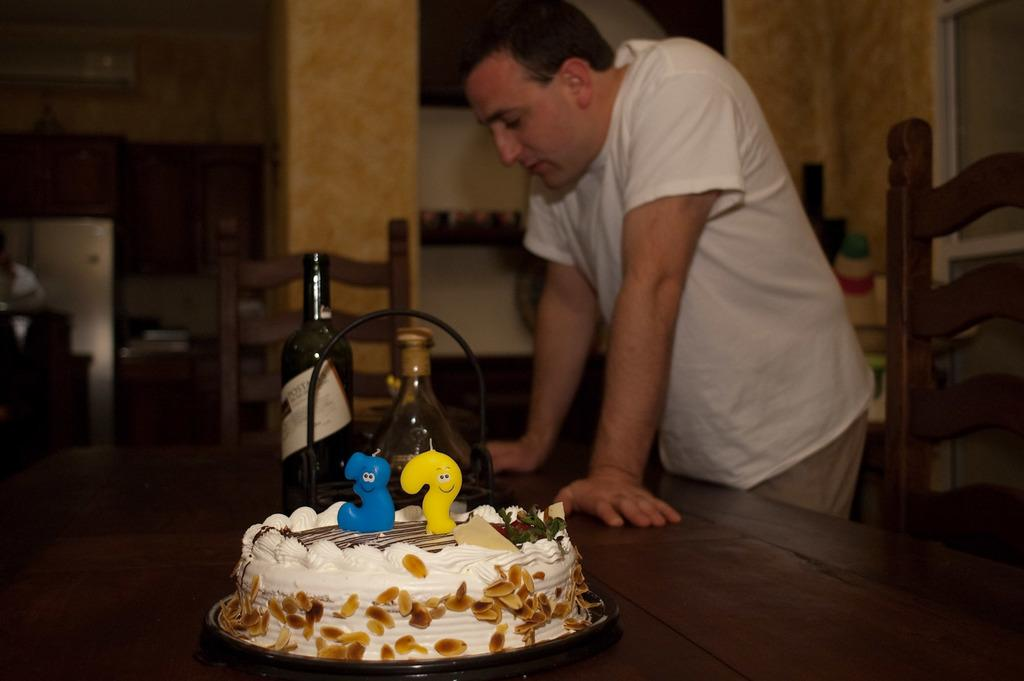What is on the table in the image? There is a cake and wine bottles on the table. Who is present in the image? A man is standing in front of the table. What might be used for seating near the table? There are chairs near the table. What can be seen in the background of the image? There is a wall in the background. What is the value of the eggnog in the image? There is no eggnog present in the image, so it is not possible to determine its value. What is the reason for the man standing in front of the table? The image does not provide any information about the man's reason for standing in front of the table. 